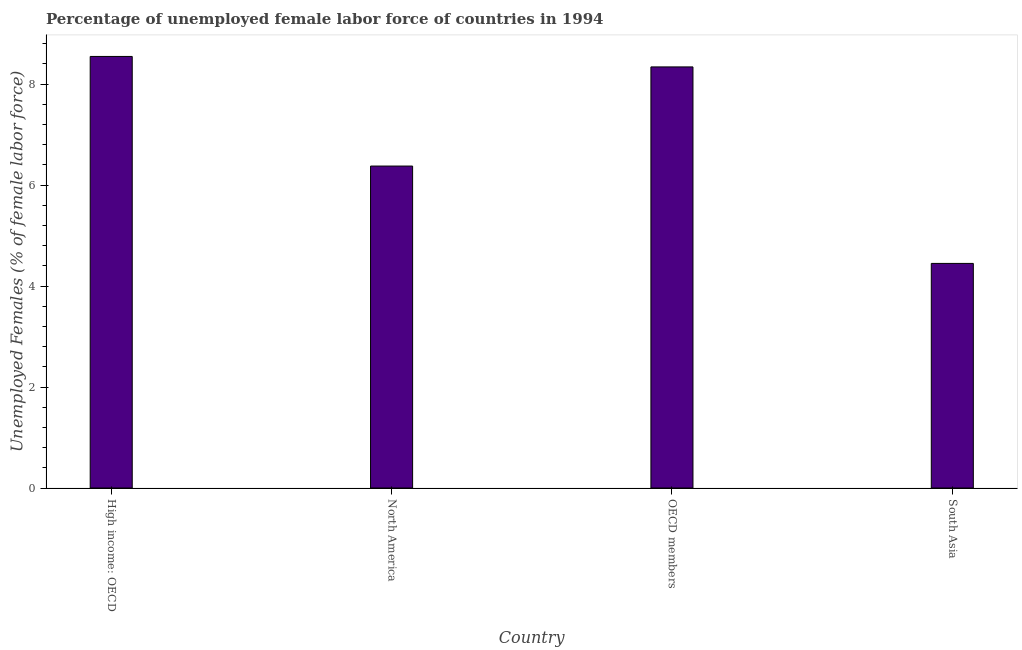Does the graph contain grids?
Keep it short and to the point. No. What is the title of the graph?
Give a very brief answer. Percentage of unemployed female labor force of countries in 1994. What is the label or title of the X-axis?
Offer a very short reply. Country. What is the label or title of the Y-axis?
Your answer should be compact. Unemployed Females (% of female labor force). What is the total unemployed female labour force in OECD members?
Provide a short and direct response. 8.34. Across all countries, what is the maximum total unemployed female labour force?
Make the answer very short. 8.55. Across all countries, what is the minimum total unemployed female labour force?
Make the answer very short. 4.45. In which country was the total unemployed female labour force maximum?
Your answer should be compact. High income: OECD. What is the sum of the total unemployed female labour force?
Your answer should be very brief. 27.71. What is the difference between the total unemployed female labour force in High income: OECD and North America?
Your answer should be compact. 2.17. What is the average total unemployed female labour force per country?
Your response must be concise. 6.93. What is the median total unemployed female labour force?
Offer a terse response. 7.36. In how many countries, is the total unemployed female labour force greater than 3.2 %?
Make the answer very short. 4. What is the ratio of the total unemployed female labour force in High income: OECD to that in South Asia?
Provide a short and direct response. 1.92. Is the total unemployed female labour force in OECD members less than that in South Asia?
Your response must be concise. No. What is the difference between the highest and the second highest total unemployed female labour force?
Your answer should be very brief. 0.21. Is the sum of the total unemployed female labour force in North America and South Asia greater than the maximum total unemployed female labour force across all countries?
Keep it short and to the point. Yes. How many bars are there?
Your response must be concise. 4. Are all the bars in the graph horizontal?
Offer a terse response. No. How many countries are there in the graph?
Make the answer very short. 4. What is the difference between two consecutive major ticks on the Y-axis?
Give a very brief answer. 2. What is the Unemployed Females (% of female labor force) in High income: OECD?
Offer a very short reply. 8.55. What is the Unemployed Females (% of female labor force) in North America?
Ensure brevity in your answer.  6.38. What is the Unemployed Females (% of female labor force) in OECD members?
Offer a very short reply. 8.34. What is the Unemployed Females (% of female labor force) in South Asia?
Offer a very short reply. 4.45. What is the difference between the Unemployed Females (% of female labor force) in High income: OECD and North America?
Offer a very short reply. 2.17. What is the difference between the Unemployed Females (% of female labor force) in High income: OECD and OECD members?
Keep it short and to the point. 0.21. What is the difference between the Unemployed Females (% of female labor force) in High income: OECD and South Asia?
Your response must be concise. 4.1. What is the difference between the Unemployed Females (% of female labor force) in North America and OECD members?
Offer a terse response. -1.96. What is the difference between the Unemployed Females (% of female labor force) in North America and South Asia?
Your response must be concise. 1.93. What is the difference between the Unemployed Females (% of female labor force) in OECD members and South Asia?
Ensure brevity in your answer.  3.89. What is the ratio of the Unemployed Females (% of female labor force) in High income: OECD to that in North America?
Provide a succinct answer. 1.34. What is the ratio of the Unemployed Females (% of female labor force) in High income: OECD to that in OECD members?
Provide a short and direct response. 1.02. What is the ratio of the Unemployed Females (% of female labor force) in High income: OECD to that in South Asia?
Your response must be concise. 1.92. What is the ratio of the Unemployed Females (% of female labor force) in North America to that in OECD members?
Offer a terse response. 0.77. What is the ratio of the Unemployed Females (% of female labor force) in North America to that in South Asia?
Your response must be concise. 1.43. What is the ratio of the Unemployed Females (% of female labor force) in OECD members to that in South Asia?
Provide a succinct answer. 1.88. 